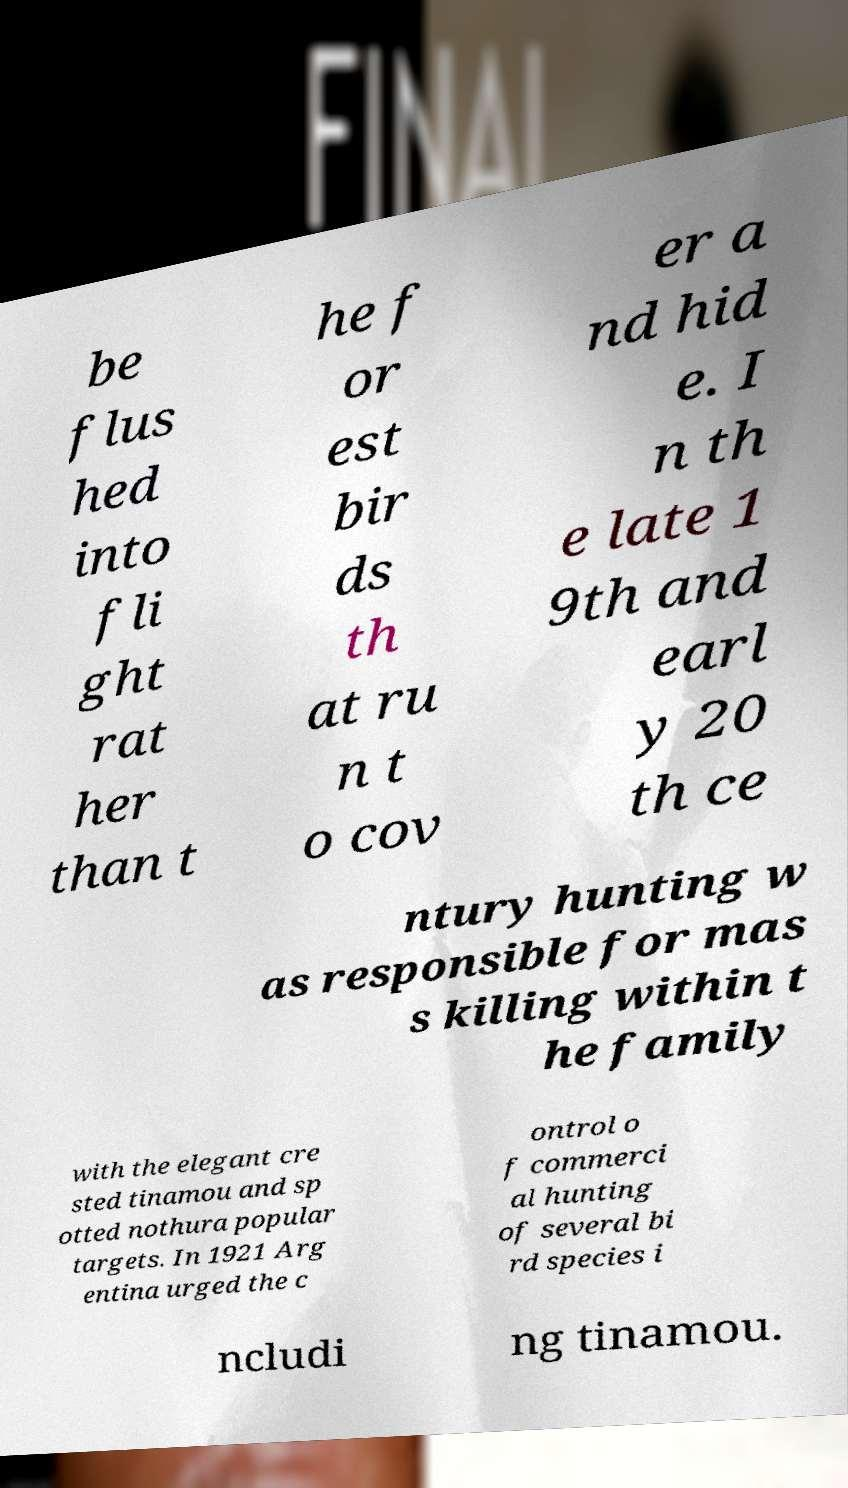Please read and relay the text visible in this image. What does it say? be flus hed into fli ght rat her than t he f or est bir ds th at ru n t o cov er a nd hid e. I n th e late 1 9th and earl y 20 th ce ntury hunting w as responsible for mas s killing within t he family with the elegant cre sted tinamou and sp otted nothura popular targets. In 1921 Arg entina urged the c ontrol o f commerci al hunting of several bi rd species i ncludi ng tinamou. 